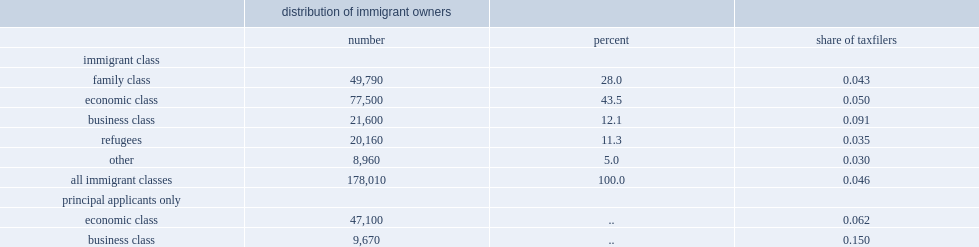What the percent of all immigrant private business owners in 2010 about economic class immigrants? 43.5. What the percent of the business class accounted for? 12.1. What the percent of immigrants entering canada through the family and refugee classes accounted for? 39.3. 